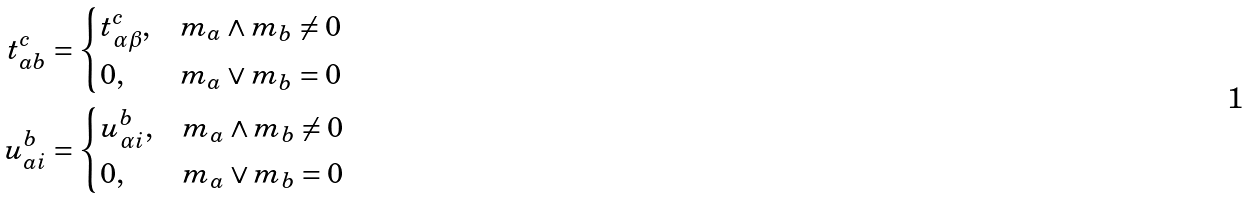<formula> <loc_0><loc_0><loc_500><loc_500>t ^ { c } _ { a b } & = \begin{cases} t ^ { c } _ { \alpha \beta } , & m _ { a } \wedge m _ { b } \neq 0 \\ 0 , & m _ { a } \vee m _ { b } = 0 \end{cases} \\ u ^ { b } _ { a i } & = \begin{cases} u ^ { b } _ { \alpha i } , & m _ { a } \wedge m _ { b } \neq 0 \\ 0 , & m _ { a } \vee m _ { b } = 0 \end{cases}</formula> 